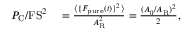<formula> <loc_0><loc_0><loc_500><loc_500>\begin{array} { r l } { P _ { C } / F S ^ { 2 } } & = \frac { \langle \{ F _ { p u r e } ( t ) \} ^ { 2 } \rangle } { A _ { R } ^ { 2 } } = \frac { ( A _ { 0 } / A _ { R } ) ^ { 2 } } { 2 } , } \end{array}</formula> 